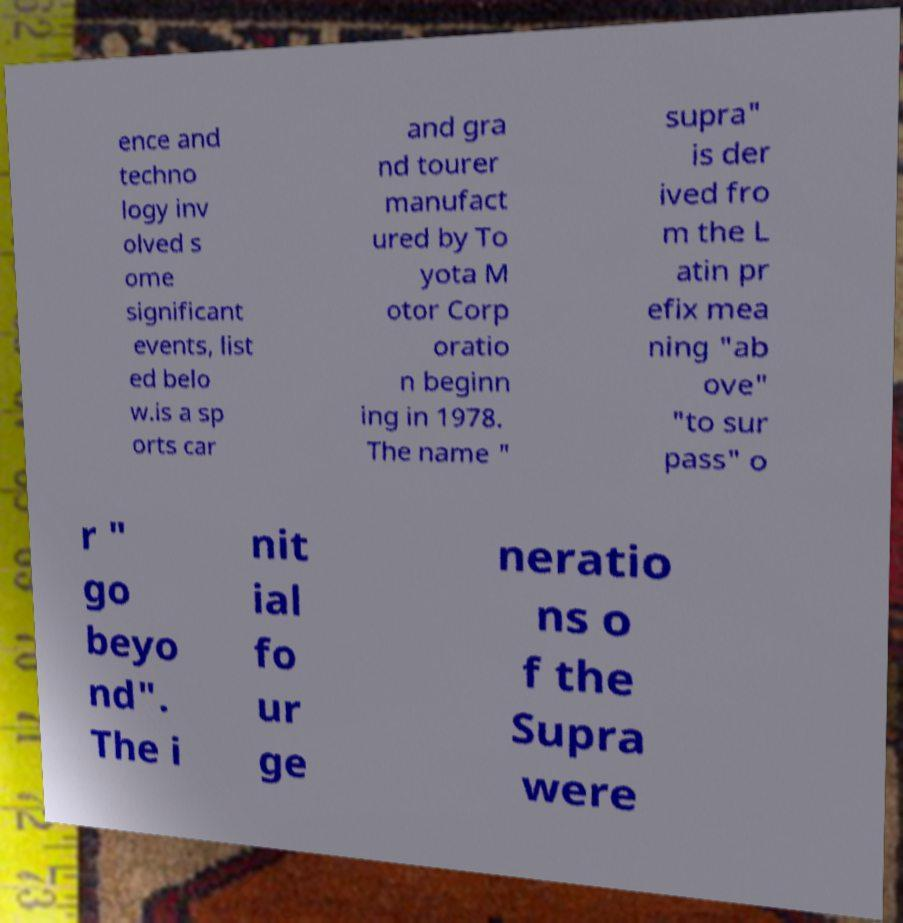Can you accurately transcribe the text from the provided image for me? ence and techno logy inv olved s ome significant events, list ed belo w.is a sp orts car and gra nd tourer manufact ured by To yota M otor Corp oratio n beginn ing in 1978. The name " supra" is der ived fro m the L atin pr efix mea ning "ab ove" "to sur pass" o r " go beyo nd". The i nit ial fo ur ge neratio ns o f the Supra were 